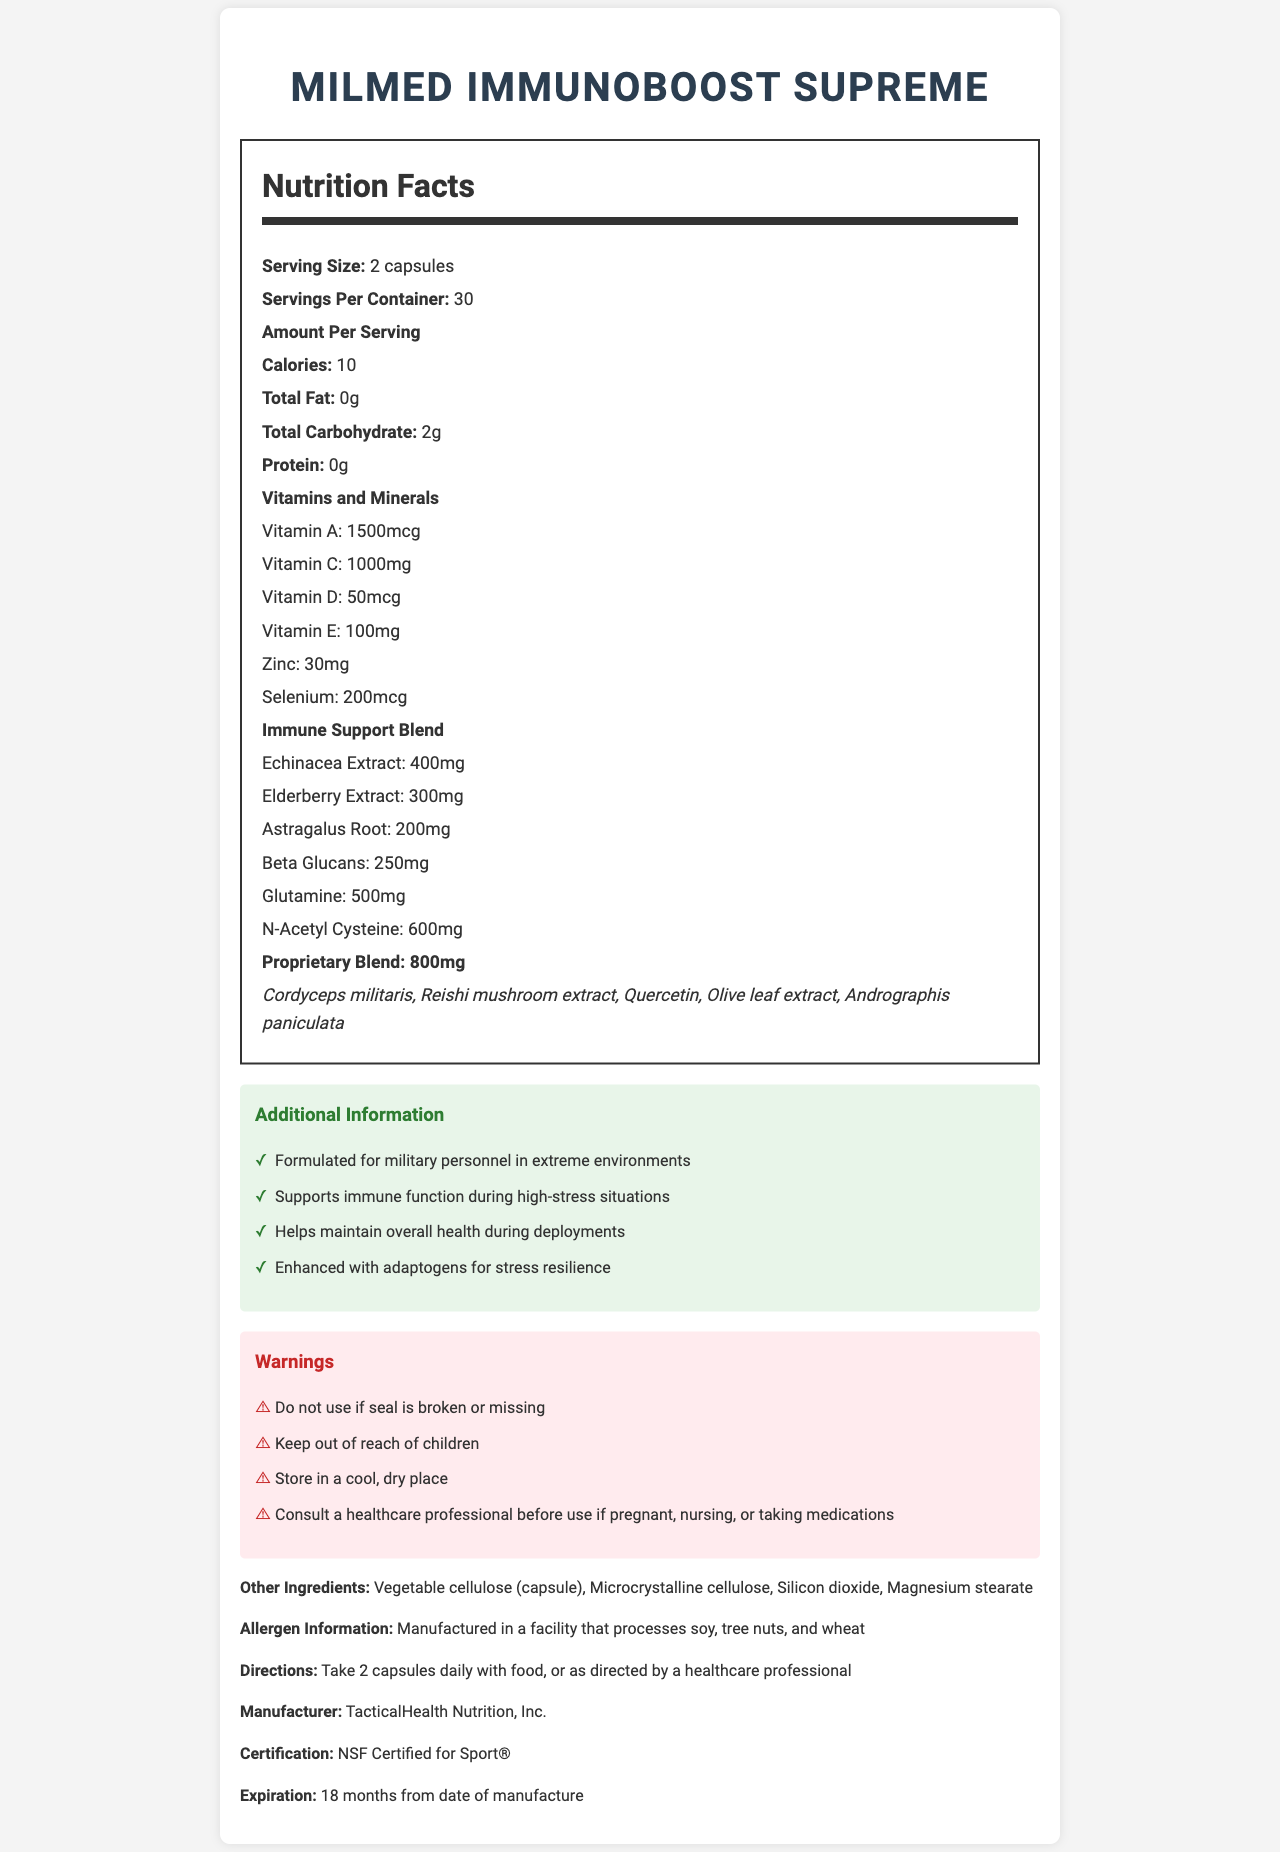what is the serving size? The document states that the serving size is "2 capsules."
Answer: 2 capsules how many vitamins are listed in the Nutrition Facts? The vitamins listed are Vitamin A, Vitamin C, Vitamin D, and Vitamin E.
Answer: 4 what is the calorie count per serving? The document lists the calorie count per serving as "10 calories."
Answer: 10 calories how much Vitamin C is in each serving? The Nutrition Facts section lists Vitamin C as 1000mg per serving.
Answer: 1000mg what are the directions for taking this supplement? The document provides directions in the form of "Take 2 capsules daily with food, or as directed by a healthcare professional."
Answer: Take 2 capsules daily with food, or as directed by a healthcare professional which ingredient is not included in the proprietary blend? A. Cordyceps militaris B. Beta Glucans C. Reishi mushroom extract D. Andrographis paniculata Beta Glucans are listed separately under the "Immune Support Blend," whereas the proprietary blend includes Cordyceps militaris, Reishi mushroom extract, and Andrographis paniculata.
Answer: B what is the ingredient warning mentioned in the document? A. Contains dairy B. Manufactured in a facility that processes soy, tree nuts, and wheat C. Contains gluten D. Contains shellfish The document specifies "Manufactured in a facility that processes soy, tree nuts, and wheat."
Answer: B is this supplement certified? The document mentions that the supplement is "NSF Certified for Sport®."
Answer: Yes does the document mention any potential allergens in this product? True/False The allergen information states that the product is manufactured in a facility that processes soy, tree nuts, and wheat.
Answer: True summarize the purpose of this document. This summary captures the comprehensive nature and primary function of the document, which is to inform users about the nutritional content, usage directions, warnings, and special formulation of the supplement.
Answer: The document provides detailed nutrition and ingredient information for MilMed ImmunoBoost Supreme, an immune-boosting dietary supplement formulated for extreme environments. It includes serving size, vitamins, minerals, directions, warnings, and additional information aimed at supporting military personnel in high-stress situations. where is this product intended to be used? The additional information section specifies that the product is formulated for military personnel in extreme environments.
Answer: Extreme environments what is the total carbohydrate content per serving? The document lists the total carbohydrate content as "2g" per serving.
Answer: 2g how many servings are in one container? The document states that there are "30 servings per container."
Answer: 30 servings what is the expiration date of the product? The document mentions that the expiration date is "18 months from date of manufacture."
Answer: 18 months from date of manufacture is there any information about the cost of the supplement? The document does not provide any details on the cost of the supplement.
Answer: Not enough information 